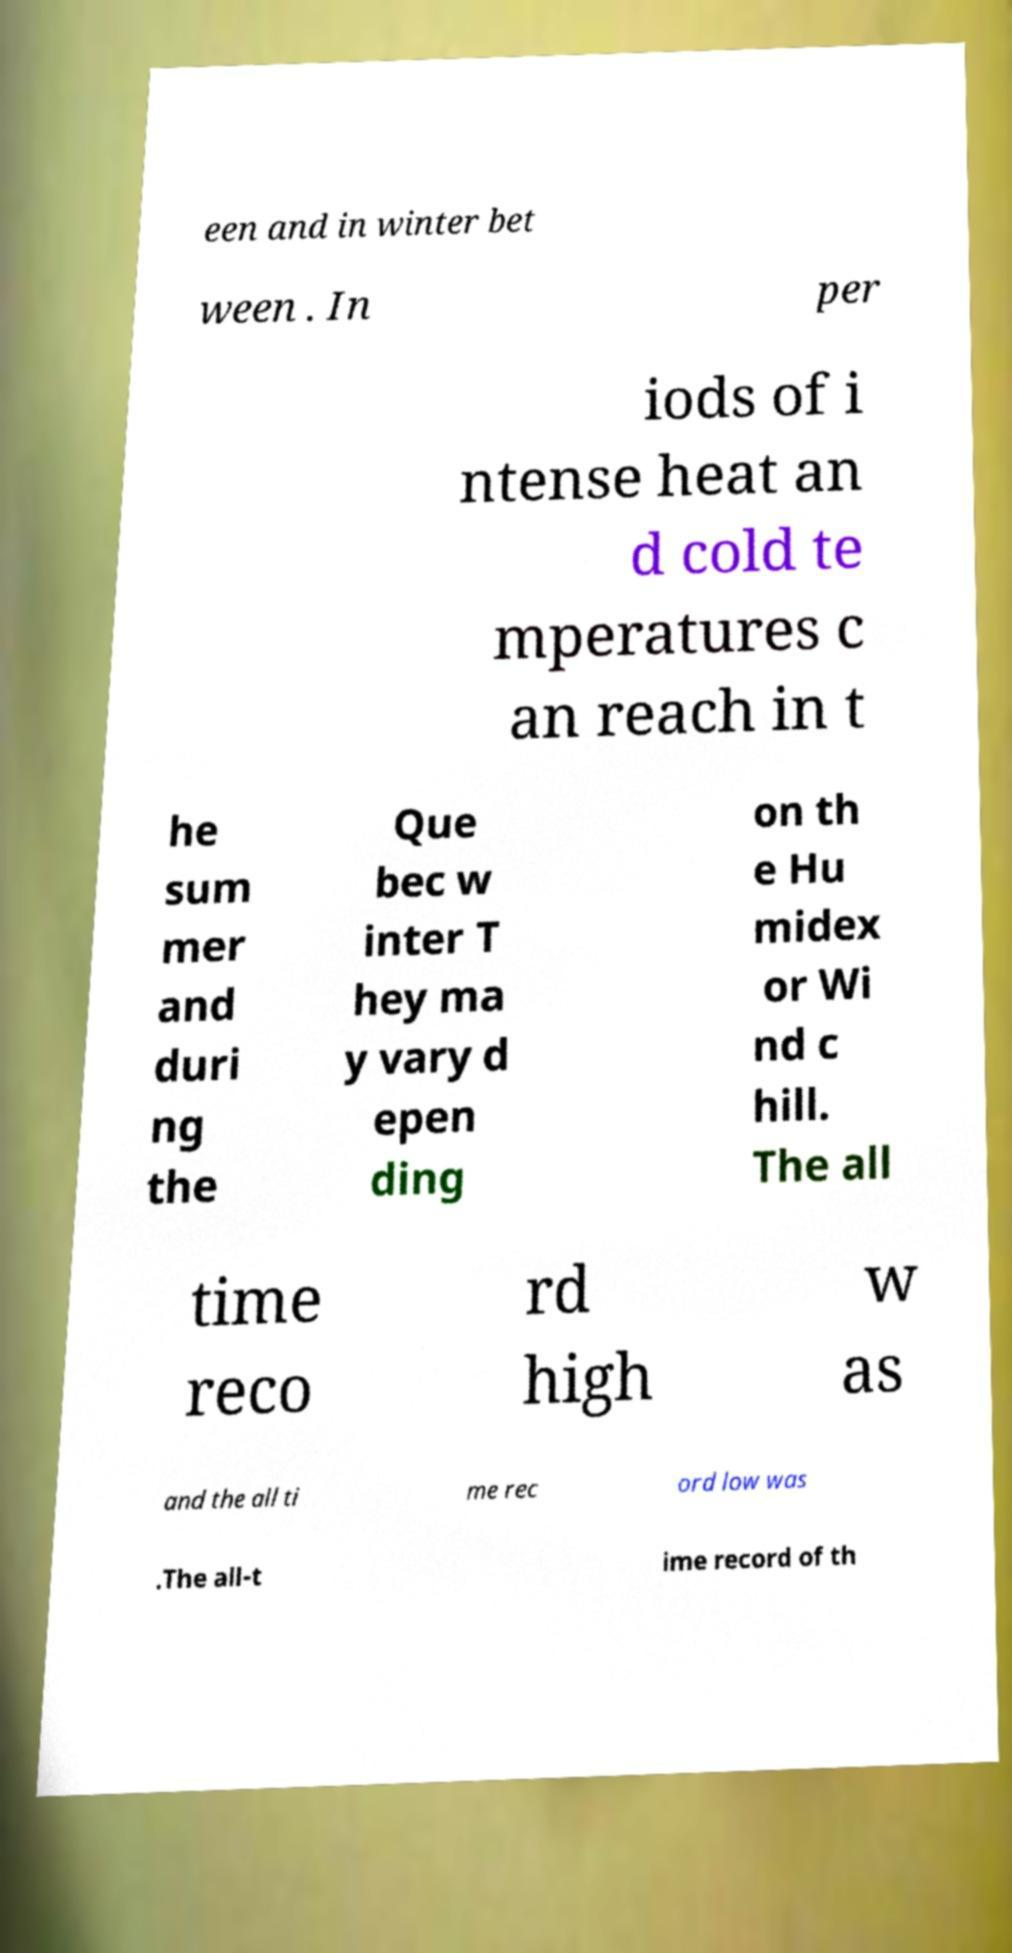Could you extract and type out the text from this image? een and in winter bet ween . In per iods of i ntense heat an d cold te mperatures c an reach in t he sum mer and duri ng the Que bec w inter T hey ma y vary d epen ding on th e Hu midex or Wi nd c hill. The all time reco rd high w as and the all ti me rec ord low was .The all-t ime record of th 